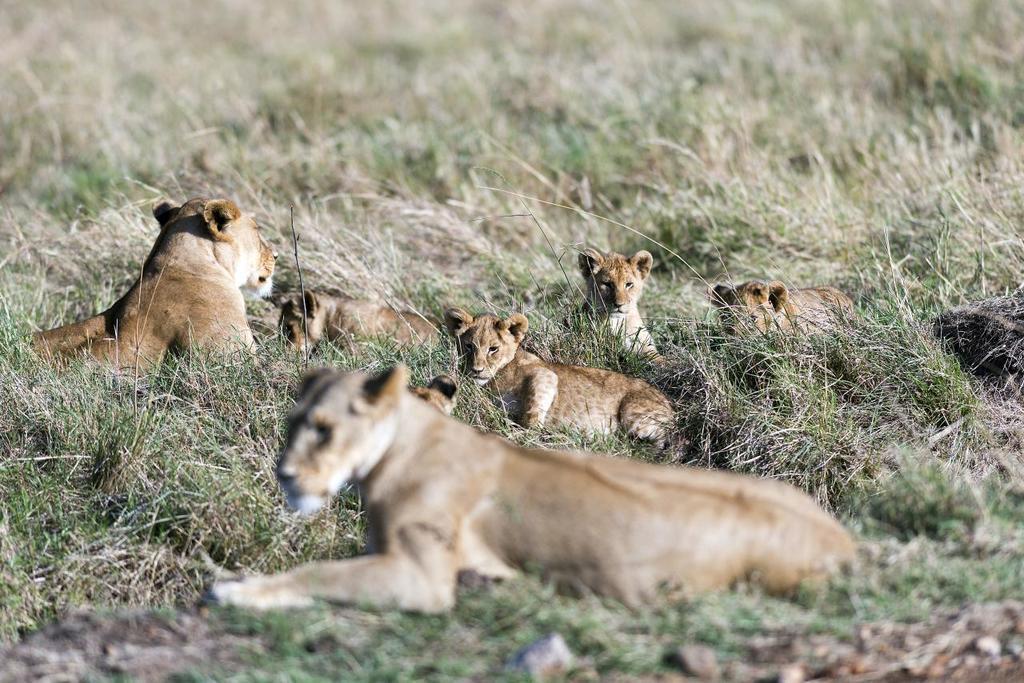Describe this image in one or two sentences. This is an outside view. At the bottom there is rock. I can see the grass on the ground. In the middle of the image there are few lions laying on the ground. 